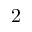<formula> <loc_0><loc_0><loc_500><loc_500>2</formula> 